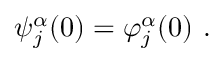<formula> <loc_0><loc_0><loc_500><loc_500>\psi _ { j } ^ { \alpha } ( 0 ) = \varphi _ { j } ^ { \alpha } ( 0 ) \ .</formula> 